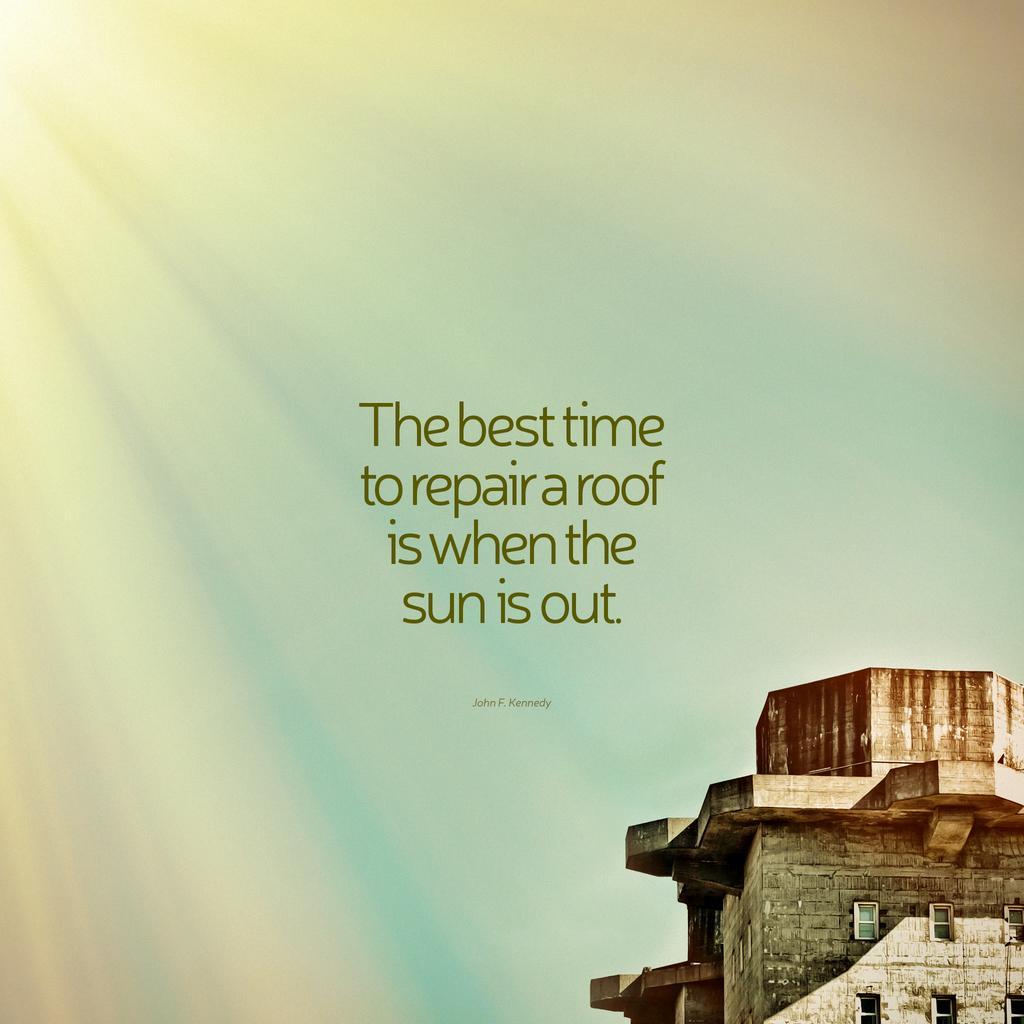Could you give a brief overview of what you see in this image? In this image I can see a building in brown and gray color. Background I can see the sky in blue and white color and I can see something written on the image. 